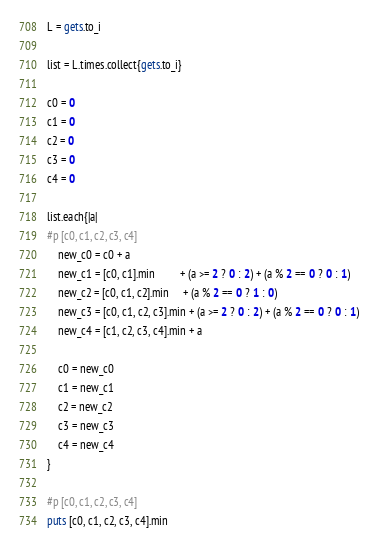Convert code to text. <code><loc_0><loc_0><loc_500><loc_500><_Ruby_>L = gets.to_i

list = L.times.collect{gets.to_i}

c0 = 0
c1 = 0
c2 = 0
c3 = 0
c4 = 0

list.each{|a|
#p [c0, c1, c2, c3, c4]
	new_c0 = c0 + a
	new_c1 = [c0, c1].min         + (a >= 2 ? 0 : 2) + (a % 2 == 0 ? 0 : 1)
	new_c2 = [c0, c1, c2].min     + (a % 2 == 0 ? 1 : 0)
	new_c3 = [c0, c1, c2, c3].min + (a >= 2 ? 0 : 2) + (a % 2 == 0 ? 0 : 1)
	new_c4 = [c1, c2, c3, c4].min + a
	
	c0 = new_c0
	c1 = new_c1
	c2 = new_c2
	c3 = new_c3
	c4 = new_c4
}

#p [c0, c1, c2, c3, c4]
puts [c0, c1, c2, c3, c4].min


</code> 